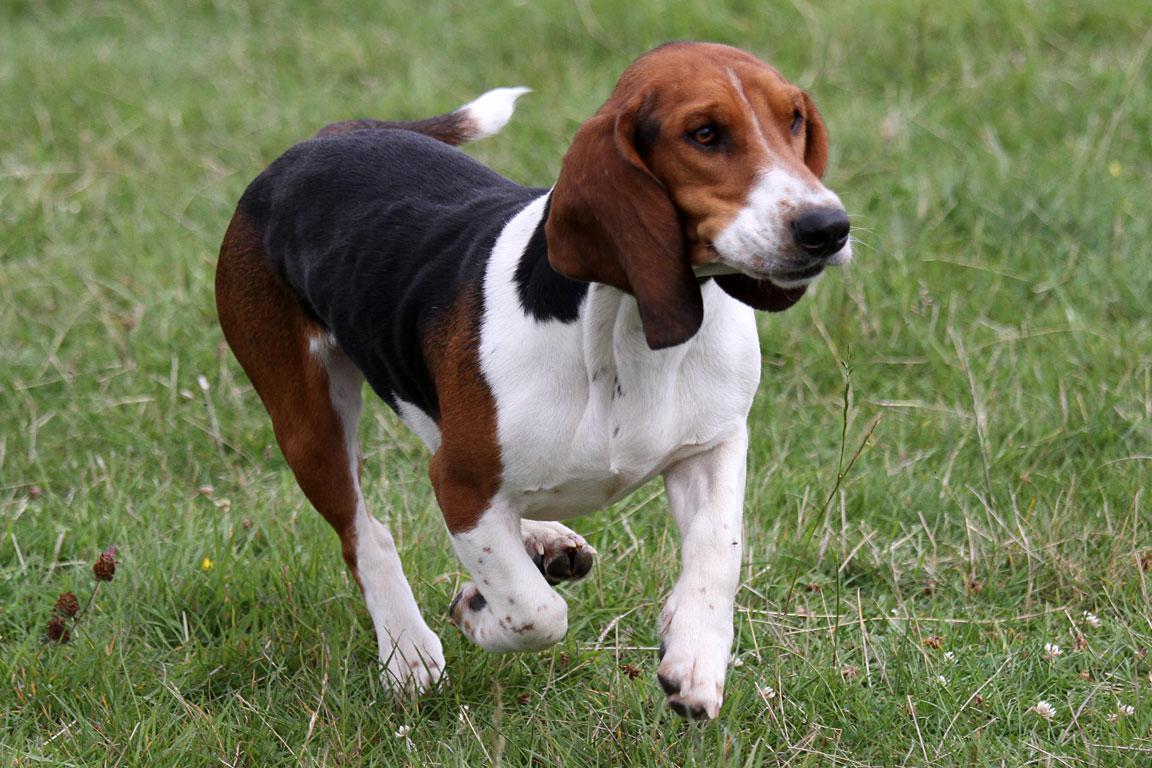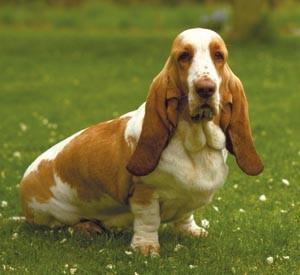The first image is the image on the left, the second image is the image on the right. Considering the images on both sides, is "In one image there is a lone basset hound standing outside facing the left side of the image." valid? Answer yes or no. No. The first image is the image on the left, the second image is the image on the right. For the images shown, is this caption "One dog is standing by itself with its tail up in the air." true? Answer yes or no. No. 